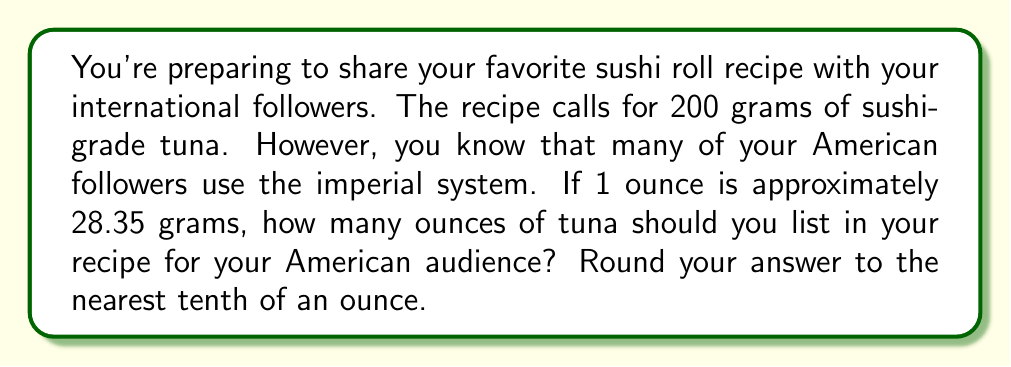Can you solve this math problem? To convert from grams to ounces, we need to divide the given weight in grams by the number of grams in an ounce. Let's break this down step-by-step:

1. Given information:
   - Recipe calls for 200 grams of tuna
   - 1 ounce ≈ 28.35 grams

2. Set up the conversion ratio:
   $$ \frac{200 \text{ grams}}{x \text{ ounces}} = \frac{28.35 \text{ grams}}{1 \text{ ounce}} $$

3. Cross multiply to solve for x:
   $$ 200 \cdot 1 = 28.35x $$
   $$ 200 = 28.35x $$

4. Divide both sides by 28.35:
   $$ x = \frac{200}{28.35} $$

5. Use a calculator to divide:
   $$ x \approx 7.0546 \text{ ounces} $$

6. Round to the nearest tenth of an ounce:
   $$ x \approx 7.1 \text{ ounces} $$

Therefore, you should list 7.1 ounces of tuna in your recipe for your American audience.
Answer: 7.1 ounces 